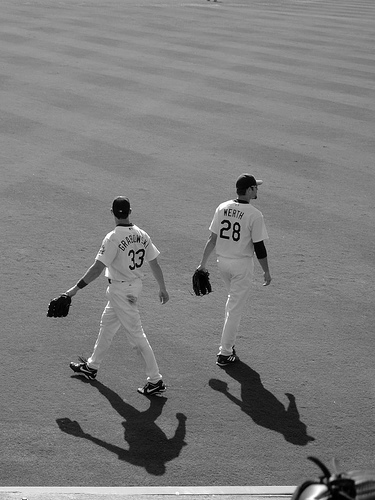Identify the text contained in this image. WERTH 28 GRABCN 33 